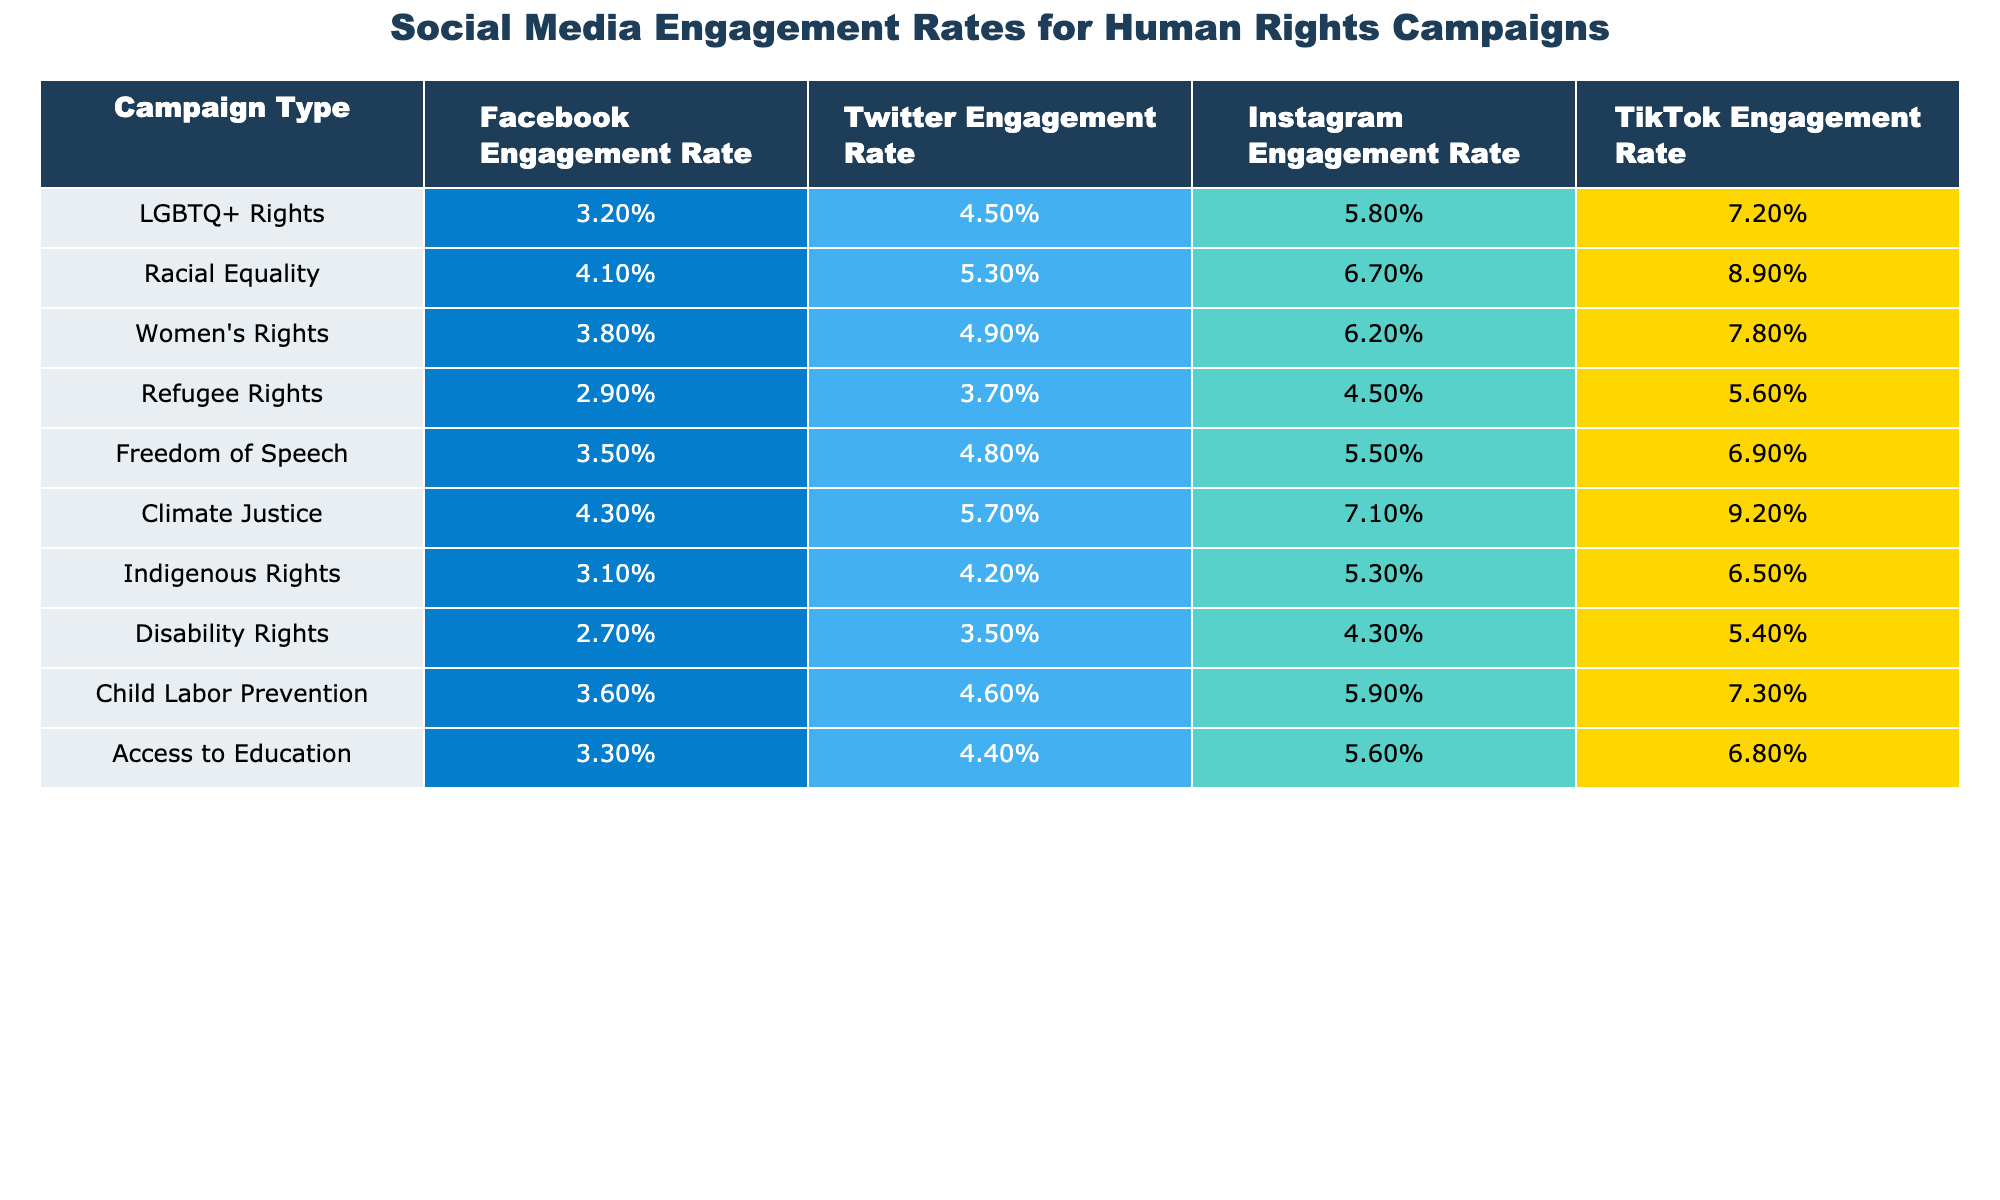What is the engagement rate for LGBTQ+ Rights on Instagram? The engagement rate for LGBTQ+ Rights on Instagram is listed directly in the table as 5.8%.
Answer: 5.8% Which campaign type has the highest TikTok Engagement Rate? The highest TikTok Engagement Rate is for Climate Justice at 9.2%, as seen in the table.
Answer: Climate Justice What is the difference in Facebook engagement rates between Racial Equality and Disability Rights? The Facebook engagement rate for Racial Equality is 4.1%, and for Disability Rights, it is 2.7%. The difference is 4.1% - 2.7% = 1.4%.
Answer: 1.4% Is the Engagement Rate for Freedom of Speech higher than that for Refugee Rights on Twitter? The engagement rate for Freedom of Speech on Twitter is 4.8%, while for Refugee Rights it is 3.7%. Since 4.8% > 3.7%, the statement is true.
Answer: Yes What is the average Instagram engagement rate across all campaign types? To find the average, sum the Instagram engagement rates: (5.8% + 6.7% + 6.2% + 4.5% + 5.5% + 7.1% + 5.3% + 4.3% + 5.9% + 5.6%)/10 = 5.6%.
Answer: 5.6% Which campaign type has the lowest engagement rate across all social media platforms? By comparing all engagement rates in the table, Disability Rights has the lowest rates: 2.7% (Facebook), 3.5% (Twitter), 4.3% (Instagram), and 5.4% (TikTok), making it the lowest overall.
Answer: Disability Rights What is the sum of the TikTok engagement rates for Women's Rights and Access to Education? The TikTok engagement rate for Women's Rights is 7.8% and for Access to Education is 6.8%. Their sum is 7.8% + 6.8% = 14.6%.
Answer: 14.6% Are the engagement rates for Climate Justice and Racial Equality on Facebook the same? The engagement rate for Climate Justice is 4.3% and for Racial Equality, it is 4.1%. Since 4.3% does not equal 4.1%, the statement is false.
Answer: No Which campaigns have an engagement rate above 5% on Instagram? From the table, the campaigns with engagement rates above 5% on Instagram are LGBTQ+ Rights (5.8%), Racial Equality (6.7%), Women's Rights (6.2%), Climate Justice (7.1%), and Child Labor Prevention (5.9%).
Answer: 5 campaigns What is the percentage difference in engagement rates on Facebook between the highest and the lowest campaign types? The highest Facebook engagement rate is 4.3% (Climate Justice) and the lowest is 2.7% (Disability Rights). The percentage difference is (4.3% - 2.7%) / 2.7% * 100 = 59.26%.
Answer: 59.26% 